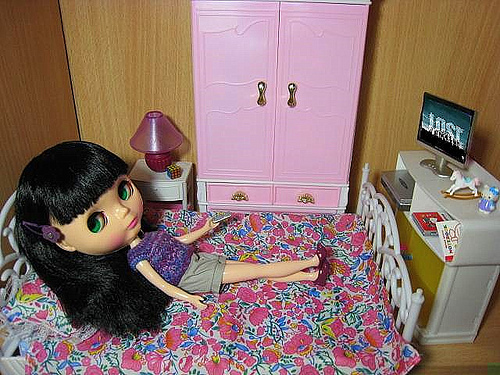Identify and read out the text in this image. LOST 